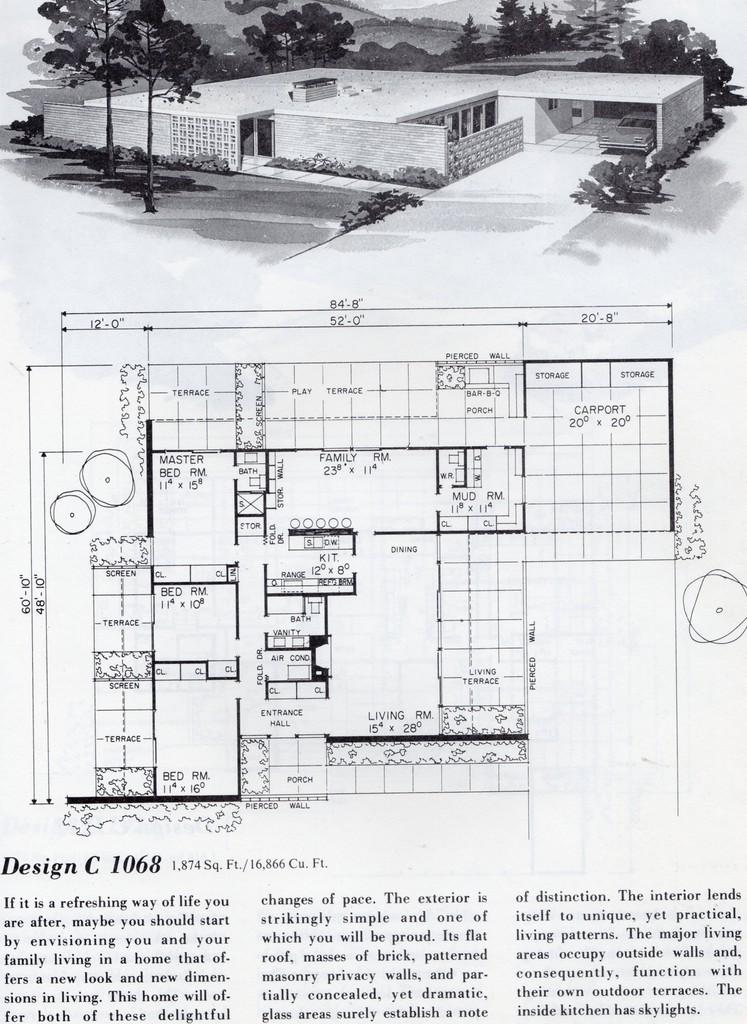What type of content is shown in the image? The image is a page of a book. What is the main feature in the center of the image? There is a diagram in the center of the image. What can be found at the bottom of the image? There is text at the bottom of the image. What is located at the top of the image? There is a building, trees, and hills at the top of the image. How does the tongue help the beginner in the image? There is no tongue or beginner present in the image; it is a page from a book with a diagram, text, and various elements at the top. 